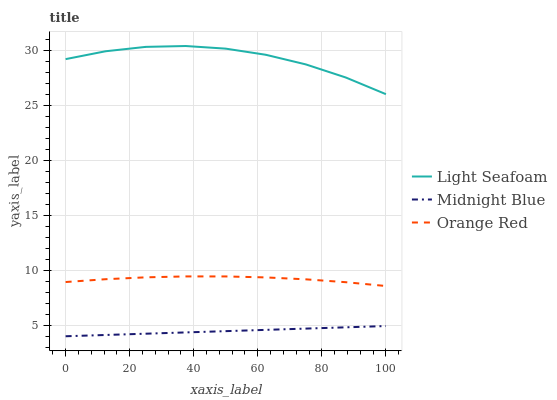Does Midnight Blue have the minimum area under the curve?
Answer yes or no. Yes. Does Light Seafoam have the maximum area under the curve?
Answer yes or no. Yes. Does Orange Red have the minimum area under the curve?
Answer yes or no. No. Does Orange Red have the maximum area under the curve?
Answer yes or no. No. Is Midnight Blue the smoothest?
Answer yes or no. Yes. Is Light Seafoam the roughest?
Answer yes or no. Yes. Is Orange Red the smoothest?
Answer yes or no. No. Is Orange Red the roughest?
Answer yes or no. No. Does Midnight Blue have the lowest value?
Answer yes or no. Yes. Does Orange Red have the lowest value?
Answer yes or no. No. Does Light Seafoam have the highest value?
Answer yes or no. Yes. Does Orange Red have the highest value?
Answer yes or no. No. Is Orange Red less than Light Seafoam?
Answer yes or no. Yes. Is Light Seafoam greater than Orange Red?
Answer yes or no. Yes. Does Orange Red intersect Light Seafoam?
Answer yes or no. No. 